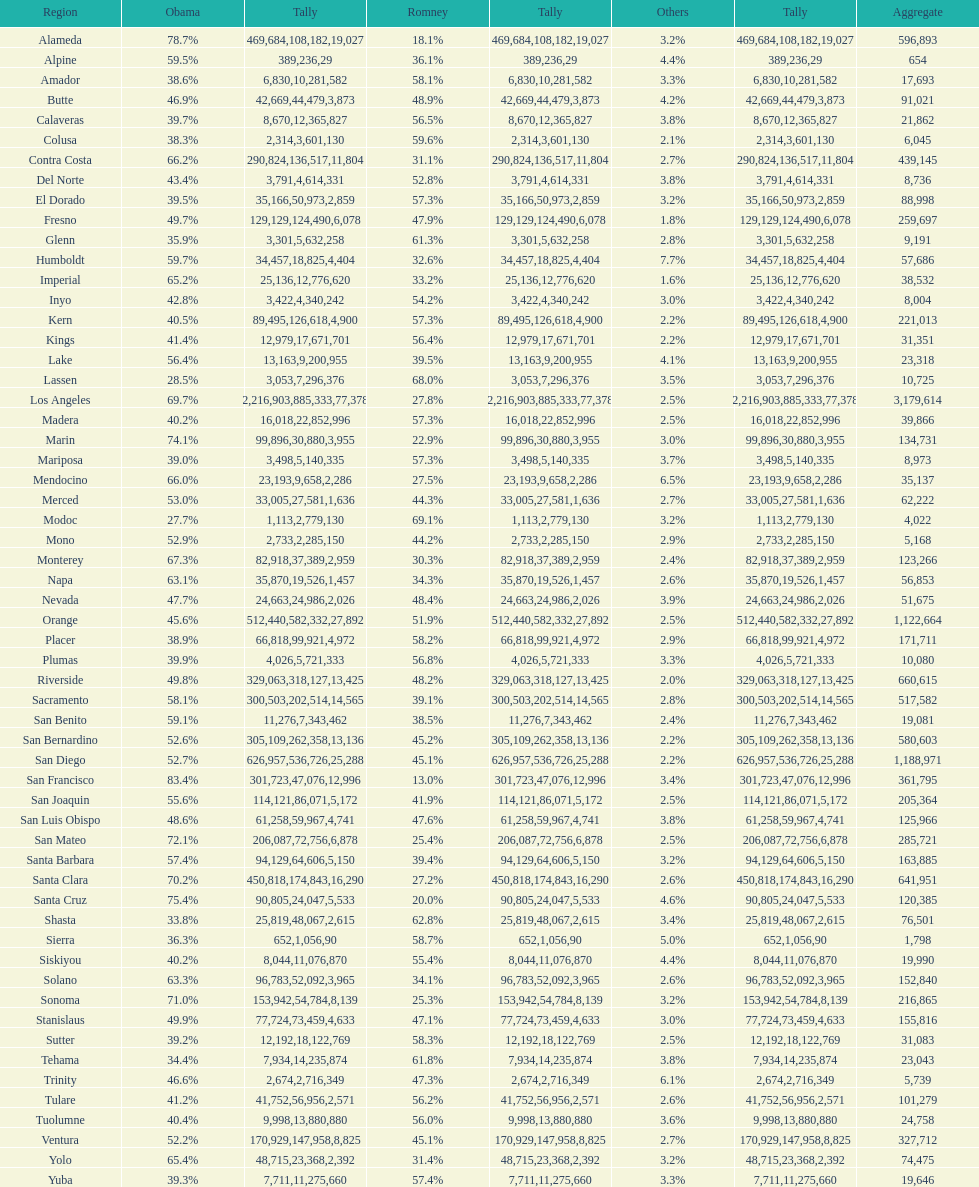What is the number of votes for obama for del norte and el dorado counties? 38957. Would you mind parsing the complete table? {'header': ['Region', 'Obama', 'Tally', 'Romney', 'Tally', 'Others', 'Tally', 'Aggregate'], 'rows': [['Alameda', '78.7%', '469,684', '18.1%', '108,182', '3.2%', '19,027', '596,893'], ['Alpine', '59.5%', '389', '36.1%', '236', '4.4%', '29', '654'], ['Amador', '38.6%', '6,830', '58.1%', '10,281', '3.3%', '582', '17,693'], ['Butte', '46.9%', '42,669', '48.9%', '44,479', '4.2%', '3,873', '91,021'], ['Calaveras', '39.7%', '8,670', '56.5%', '12,365', '3.8%', '827', '21,862'], ['Colusa', '38.3%', '2,314', '59.6%', '3,601', '2.1%', '130', '6,045'], ['Contra Costa', '66.2%', '290,824', '31.1%', '136,517', '2.7%', '11,804', '439,145'], ['Del Norte', '43.4%', '3,791', '52.8%', '4,614', '3.8%', '331', '8,736'], ['El Dorado', '39.5%', '35,166', '57.3%', '50,973', '3.2%', '2,859', '88,998'], ['Fresno', '49.7%', '129,129', '47.9%', '124,490', '1.8%', '6,078', '259,697'], ['Glenn', '35.9%', '3,301', '61.3%', '5,632', '2.8%', '258', '9,191'], ['Humboldt', '59.7%', '34,457', '32.6%', '18,825', '7.7%', '4,404', '57,686'], ['Imperial', '65.2%', '25,136', '33.2%', '12,776', '1.6%', '620', '38,532'], ['Inyo', '42.8%', '3,422', '54.2%', '4,340', '3.0%', '242', '8,004'], ['Kern', '40.5%', '89,495', '57.3%', '126,618', '2.2%', '4,900', '221,013'], ['Kings', '41.4%', '12,979', '56.4%', '17,671', '2.2%', '701', '31,351'], ['Lake', '56.4%', '13,163', '39.5%', '9,200', '4.1%', '955', '23,318'], ['Lassen', '28.5%', '3,053', '68.0%', '7,296', '3.5%', '376', '10,725'], ['Los Angeles', '69.7%', '2,216,903', '27.8%', '885,333', '2.5%', '77,378', '3,179,614'], ['Madera', '40.2%', '16,018', '57.3%', '22,852', '2.5%', '996', '39,866'], ['Marin', '74.1%', '99,896', '22.9%', '30,880', '3.0%', '3,955', '134,731'], ['Mariposa', '39.0%', '3,498', '57.3%', '5,140', '3.7%', '335', '8,973'], ['Mendocino', '66.0%', '23,193', '27.5%', '9,658', '6.5%', '2,286', '35,137'], ['Merced', '53.0%', '33,005', '44.3%', '27,581', '2.7%', '1,636', '62,222'], ['Modoc', '27.7%', '1,113', '69.1%', '2,779', '3.2%', '130', '4,022'], ['Mono', '52.9%', '2,733', '44.2%', '2,285', '2.9%', '150', '5,168'], ['Monterey', '67.3%', '82,918', '30.3%', '37,389', '2.4%', '2,959', '123,266'], ['Napa', '63.1%', '35,870', '34.3%', '19,526', '2.6%', '1,457', '56,853'], ['Nevada', '47.7%', '24,663', '48.4%', '24,986', '3.9%', '2,026', '51,675'], ['Orange', '45.6%', '512,440', '51.9%', '582,332', '2.5%', '27,892', '1,122,664'], ['Placer', '38.9%', '66,818', '58.2%', '99,921', '2.9%', '4,972', '171,711'], ['Plumas', '39.9%', '4,026', '56.8%', '5,721', '3.3%', '333', '10,080'], ['Riverside', '49.8%', '329,063', '48.2%', '318,127', '2.0%', '13,425', '660,615'], ['Sacramento', '58.1%', '300,503', '39.1%', '202,514', '2.8%', '14,565', '517,582'], ['San Benito', '59.1%', '11,276', '38.5%', '7,343', '2.4%', '462', '19,081'], ['San Bernardino', '52.6%', '305,109', '45.2%', '262,358', '2.2%', '13,136', '580,603'], ['San Diego', '52.7%', '626,957', '45.1%', '536,726', '2.2%', '25,288', '1,188,971'], ['San Francisco', '83.4%', '301,723', '13.0%', '47,076', '3.4%', '12,996', '361,795'], ['San Joaquin', '55.6%', '114,121', '41.9%', '86,071', '2.5%', '5,172', '205,364'], ['San Luis Obispo', '48.6%', '61,258', '47.6%', '59,967', '3.8%', '4,741', '125,966'], ['San Mateo', '72.1%', '206,087', '25.4%', '72,756', '2.5%', '6,878', '285,721'], ['Santa Barbara', '57.4%', '94,129', '39.4%', '64,606', '3.2%', '5,150', '163,885'], ['Santa Clara', '70.2%', '450,818', '27.2%', '174,843', '2.6%', '16,290', '641,951'], ['Santa Cruz', '75.4%', '90,805', '20.0%', '24,047', '4.6%', '5,533', '120,385'], ['Shasta', '33.8%', '25,819', '62.8%', '48,067', '3.4%', '2,615', '76,501'], ['Sierra', '36.3%', '652', '58.7%', '1,056', '5.0%', '90', '1,798'], ['Siskiyou', '40.2%', '8,044', '55.4%', '11,076', '4.4%', '870', '19,990'], ['Solano', '63.3%', '96,783', '34.1%', '52,092', '2.6%', '3,965', '152,840'], ['Sonoma', '71.0%', '153,942', '25.3%', '54,784', '3.2%', '8,139', '216,865'], ['Stanislaus', '49.9%', '77,724', '47.1%', '73,459', '3.0%', '4,633', '155,816'], ['Sutter', '39.2%', '12,192', '58.3%', '18,122', '2.5%', '769', '31,083'], ['Tehama', '34.4%', '7,934', '61.8%', '14,235', '3.8%', '874', '23,043'], ['Trinity', '46.6%', '2,674', '47.3%', '2,716', '6.1%', '349', '5,739'], ['Tulare', '41.2%', '41,752', '56.2%', '56,956', '2.6%', '2,571', '101,279'], ['Tuolumne', '40.4%', '9,998', '56.0%', '13,880', '3.6%', '880', '24,758'], ['Ventura', '52.2%', '170,929', '45.1%', '147,958', '2.7%', '8,825', '327,712'], ['Yolo', '65.4%', '48,715', '31.4%', '23,368', '3.2%', '2,392', '74,475'], ['Yuba', '39.3%', '7,711', '57.4%', '11,275', '3.3%', '660', '19,646']]} 